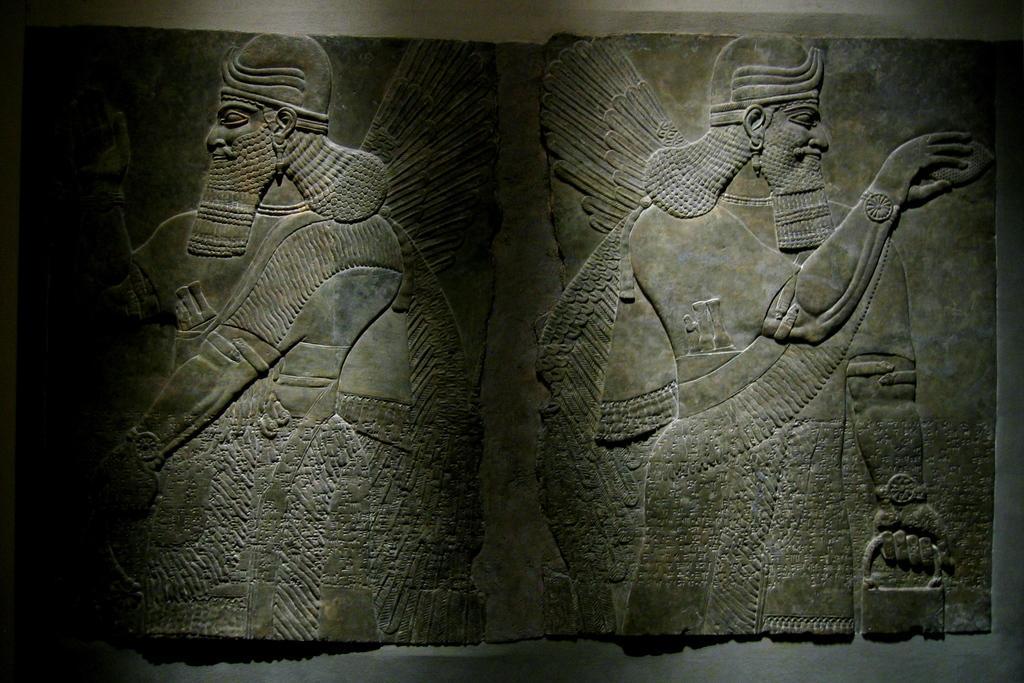Can you describe this image briefly? In this picture, we see a carved stone. In the background, we see a wall. 